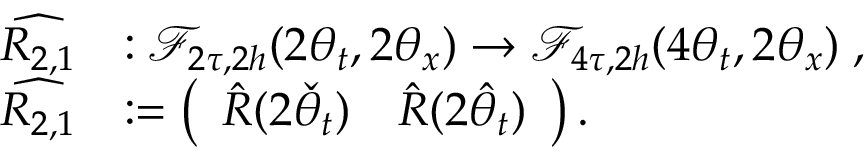<formula> <loc_0><loc_0><loc_500><loc_500>\begin{array} { r l } { \widehat { R _ { 2 , 1 } } } & { \colon \mathcal { F } _ { 2 \tau , 2 h } ( 2 \theta _ { t } , 2 \theta _ { x } ) \to \mathcal { F } _ { 4 \tau , 2 h } ( 4 \theta _ { t } , 2 \theta _ { x } ) \, , } \\ { \widehat { R _ { 2 , 1 } } } & { \colon = \left ( \begin{array} { l l } { \hat { R } ( 2 \check { \theta } _ { t } ) } & { \hat { R } ( 2 \hat { \theta } _ { t } ) } \end{array} \right ) . } \end{array}</formula> 